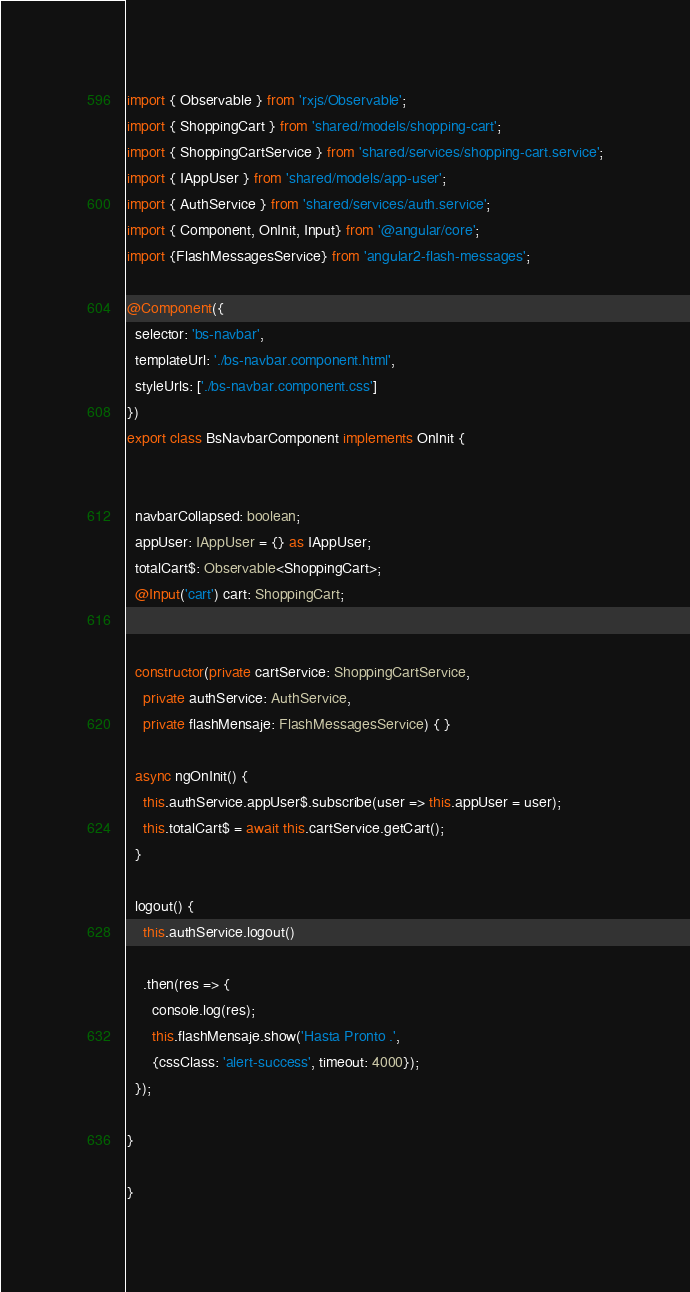<code> <loc_0><loc_0><loc_500><loc_500><_TypeScript_>import { Observable } from 'rxjs/Observable';
import { ShoppingCart } from 'shared/models/shopping-cart';
import { ShoppingCartService } from 'shared/services/shopping-cart.service';
import { IAppUser } from 'shared/models/app-user';
import { AuthService } from 'shared/services/auth.service';
import { Component, OnInit, Input} from '@angular/core';
import {FlashMessagesService} from 'angular2-flash-messages';

@Component({
  selector: 'bs-navbar',
  templateUrl: './bs-navbar.component.html',
  styleUrls: ['./bs-navbar.component.css']
})
export class BsNavbarComponent implements OnInit {


  navbarCollapsed: boolean;
  appUser: IAppUser = {} as IAppUser;
  totalCart$: Observable<ShoppingCart>;
  @Input('cart') cart: ShoppingCart;


  constructor(private cartService: ShoppingCartService, 
    private authService: AuthService,
    private flashMensaje: FlashMessagesService) { }

  async ngOnInit() {
    this.authService.appUser$.subscribe(user => this.appUser = user);
    this.totalCart$ = await this.cartService.getCart();
  }

  logout() {
    this.authService.logout()

    .then(res => {
      console.log(res);
      this.flashMensaje.show('Hasta Pronto .',
      {cssClass: 'alert-success', timeout: 4000});
  });

}

}
</code> 